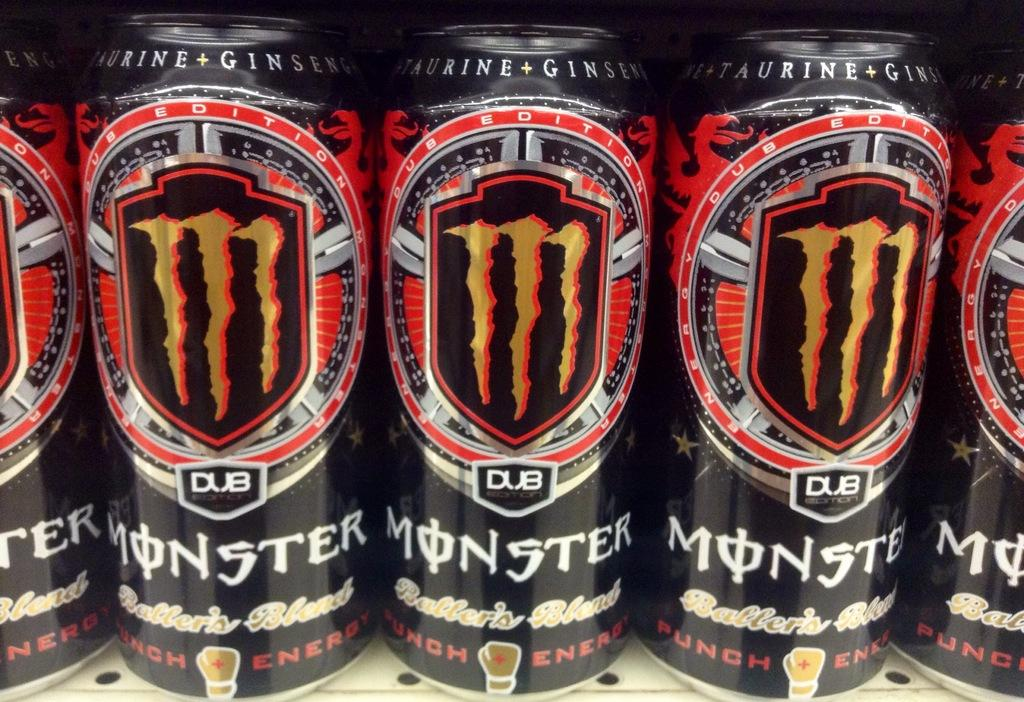<image>
Summarize the visual content of the image. A row of energy drinks that say Monster are on a store shelf. 